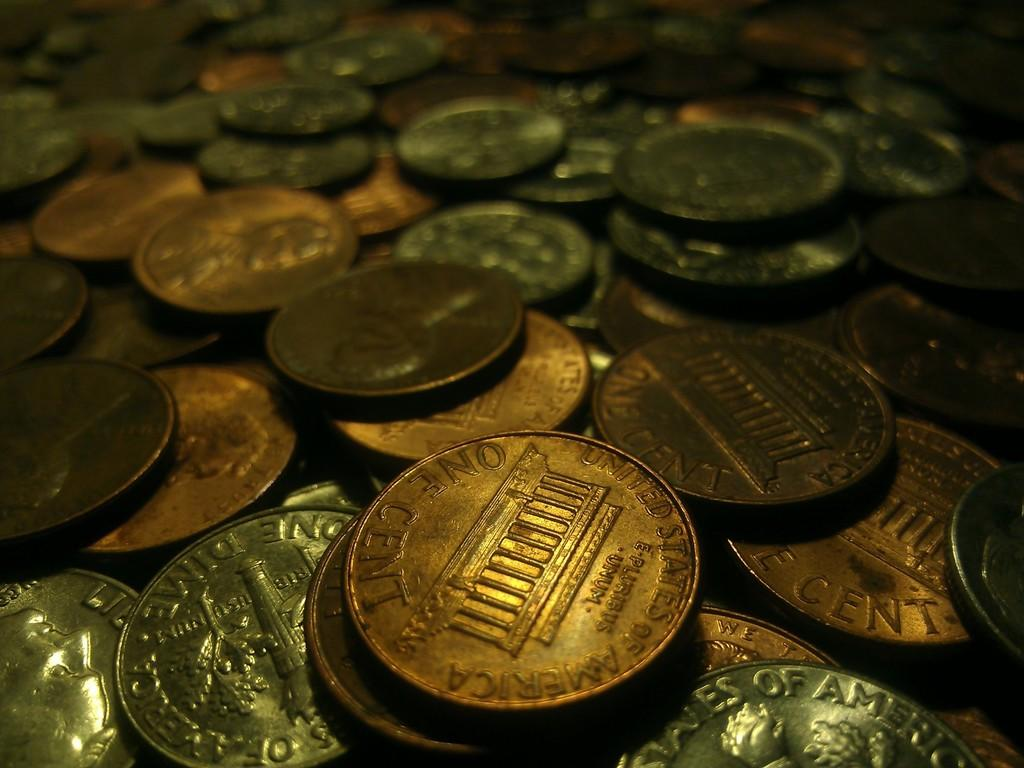<image>
Provide a brief description of the given image. Pennies and dimes are among the large collection of coins. 